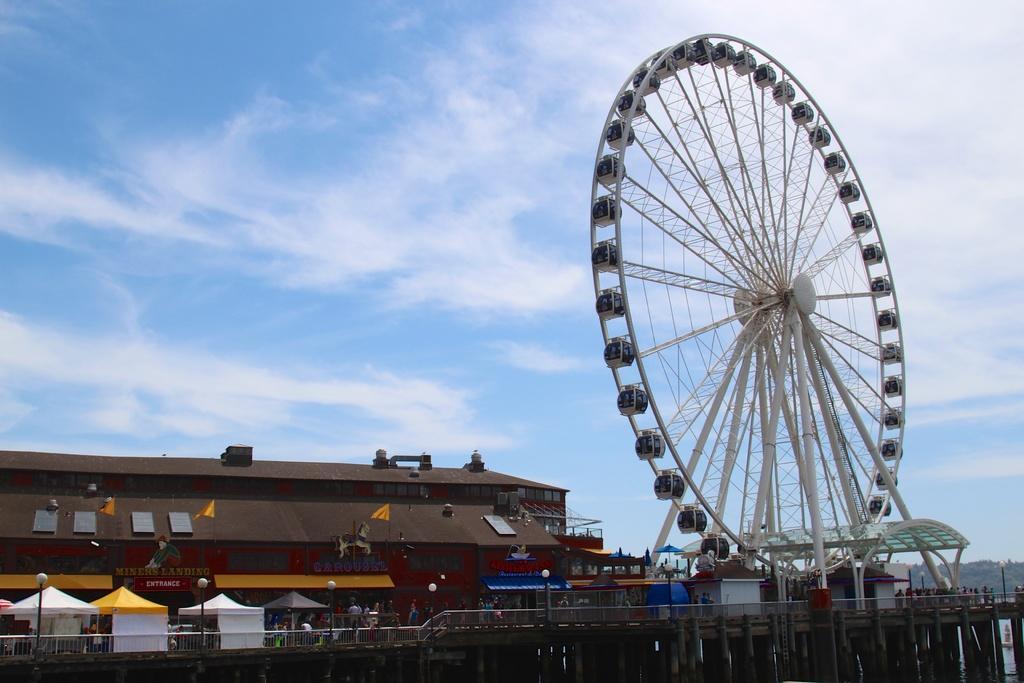Can you describe this image briefly? In the background we can see a clear blue sky with clouds. In this picture we can see flags, stores, boards. We can see a giant wheel, railing, people and some stalls. At the bottom portion of the picture we can see water and a bridge. 